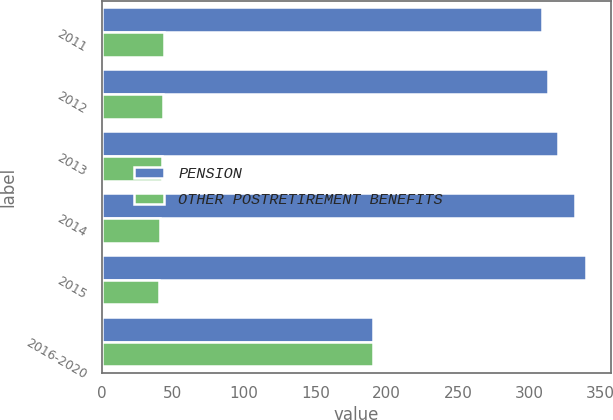Convert chart. <chart><loc_0><loc_0><loc_500><loc_500><stacked_bar_chart><ecel><fcel>2011<fcel>2012<fcel>2013<fcel>2014<fcel>2015<fcel>2016-2020<nl><fcel>PENSION<fcel>309<fcel>313<fcel>320<fcel>332<fcel>340<fcel>190<nl><fcel>OTHER POSTRETIREMENT BENEFITS<fcel>44<fcel>43<fcel>42<fcel>41<fcel>40<fcel>190<nl></chart> 